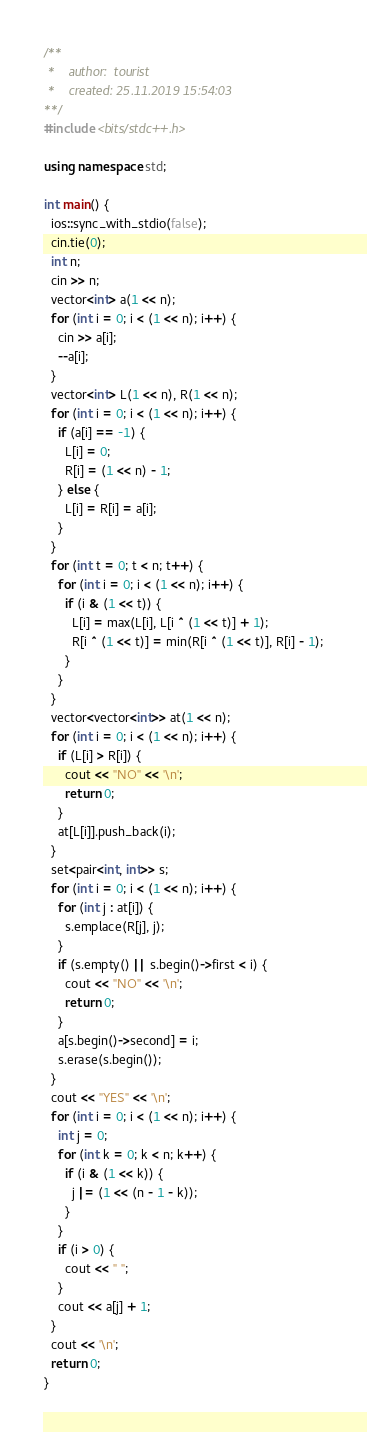Convert code to text. <code><loc_0><loc_0><loc_500><loc_500><_C++_>/**
 *    author:  tourist
 *    created: 25.11.2019 15:54:03       
**/
#include <bits/stdc++.h>

using namespace std;

int main() {
  ios::sync_with_stdio(false);
  cin.tie(0);
  int n;
  cin >> n;
  vector<int> a(1 << n);
  for (int i = 0; i < (1 << n); i++) {
    cin >> a[i];
    --a[i];
  }
  vector<int> L(1 << n), R(1 << n);
  for (int i = 0; i < (1 << n); i++) {
    if (a[i] == -1) {
      L[i] = 0;
      R[i] = (1 << n) - 1;
    } else {
      L[i] = R[i] = a[i];
    }
  }
  for (int t = 0; t < n; t++) {
    for (int i = 0; i < (1 << n); i++) {
      if (i & (1 << t)) {
        L[i] = max(L[i], L[i ^ (1 << t)] + 1);
        R[i ^ (1 << t)] = min(R[i ^ (1 << t)], R[i] - 1);
      }
    }
  }
  vector<vector<int>> at(1 << n);
  for (int i = 0; i < (1 << n); i++) {
    if (L[i] > R[i]) {
      cout << "NO" << '\n';
      return 0;
    }
    at[L[i]].push_back(i);
  }
  set<pair<int, int>> s;
  for (int i = 0; i < (1 << n); i++) {
    for (int j : at[i]) {
      s.emplace(R[j], j);
    }
    if (s.empty() || s.begin()->first < i) {
      cout << "NO" << '\n';
      return 0;
    }
    a[s.begin()->second] = i;
    s.erase(s.begin());
  }
  cout << "YES" << '\n';
  for (int i = 0; i < (1 << n); i++) {
    int j = 0;
    for (int k = 0; k < n; k++) {
      if (i & (1 << k)) {
        j |= (1 << (n - 1 - k));
      }
    }
    if (i > 0) {
      cout << " ";
    }
    cout << a[j] + 1;
  }
  cout << '\n';
  return 0;
}
</code> 